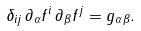Convert formula to latex. <formula><loc_0><loc_0><loc_500><loc_500>\delta _ { i j } \, \partial _ { \alpha } f ^ { i } \, \partial _ { \beta } f ^ { j } = g _ { \alpha \beta } .</formula> 